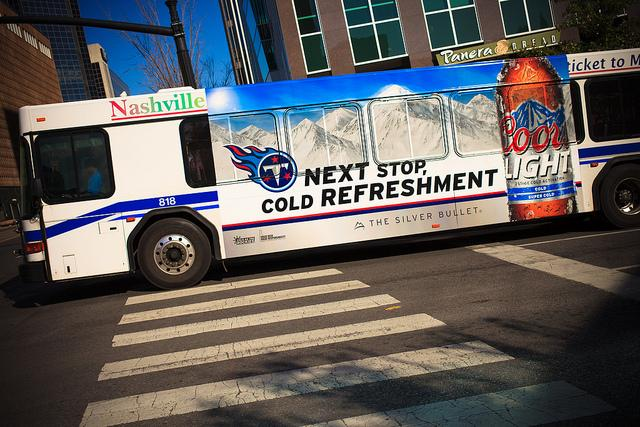Who is the road for?

Choices:
A) pedestrians
B) trucks
C) bicycles
D) drivers drivers 